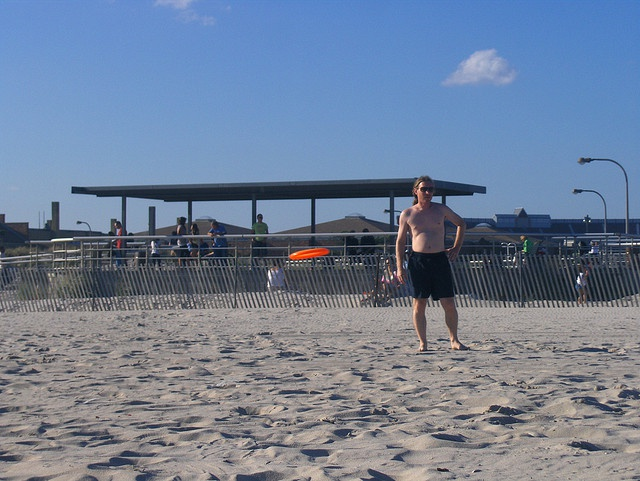Describe the objects in this image and their specific colors. I can see people in gray and black tones, people in gray, black, teal, and purple tones, people in gray, black, and navy tones, people in gray, black, and blue tones, and people in gray, black, and darkgray tones in this image. 